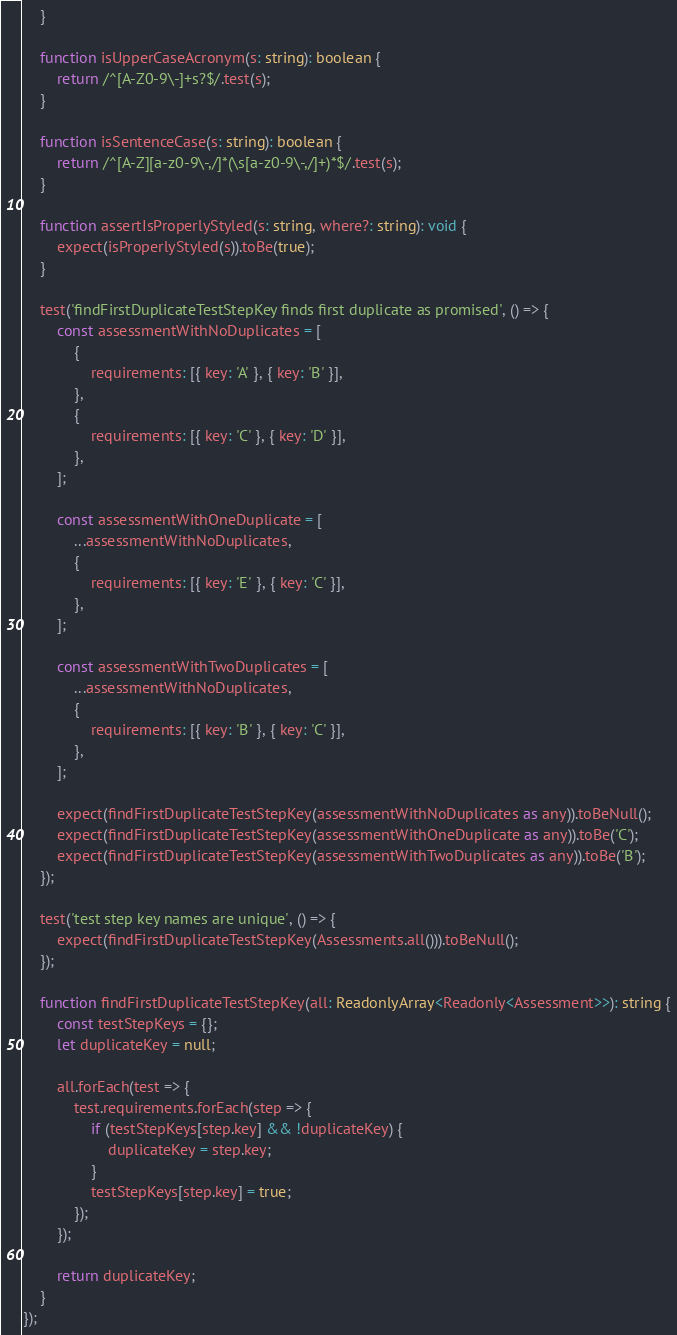<code> <loc_0><loc_0><loc_500><loc_500><_TypeScript_>    }

    function isUpperCaseAcronym(s: string): boolean {
        return /^[A-Z0-9\-]+s?$/.test(s);
    }

    function isSentenceCase(s: string): boolean {
        return /^[A-Z][a-z0-9\-,/]*(\s[a-z0-9\-,/]+)*$/.test(s);
    }

    function assertIsProperlyStyled(s: string, where?: string): void {
        expect(isProperlyStyled(s)).toBe(true);
    }

    test('findFirstDuplicateTestStepKey finds first duplicate as promised', () => {
        const assessmentWithNoDuplicates = [
            {
                requirements: [{ key: 'A' }, { key: 'B' }],
            },
            {
                requirements: [{ key: 'C' }, { key: 'D' }],
            },
        ];

        const assessmentWithOneDuplicate = [
            ...assessmentWithNoDuplicates,
            {
                requirements: [{ key: 'E' }, { key: 'C' }],
            },
        ];

        const assessmentWithTwoDuplicates = [
            ...assessmentWithNoDuplicates,
            {
                requirements: [{ key: 'B' }, { key: 'C' }],
            },
        ];

        expect(findFirstDuplicateTestStepKey(assessmentWithNoDuplicates as any)).toBeNull();
        expect(findFirstDuplicateTestStepKey(assessmentWithOneDuplicate as any)).toBe('C');
        expect(findFirstDuplicateTestStepKey(assessmentWithTwoDuplicates as any)).toBe('B');
    });

    test('test step key names are unique', () => {
        expect(findFirstDuplicateTestStepKey(Assessments.all())).toBeNull();
    });

    function findFirstDuplicateTestStepKey(all: ReadonlyArray<Readonly<Assessment>>): string {
        const testStepKeys = {};
        let duplicateKey = null;

        all.forEach(test => {
            test.requirements.forEach(step => {
                if (testStepKeys[step.key] && !duplicateKey) {
                    duplicateKey = step.key;
                }
                testStepKeys[step.key] = true;
            });
        });

        return duplicateKey;
    }
});
</code> 